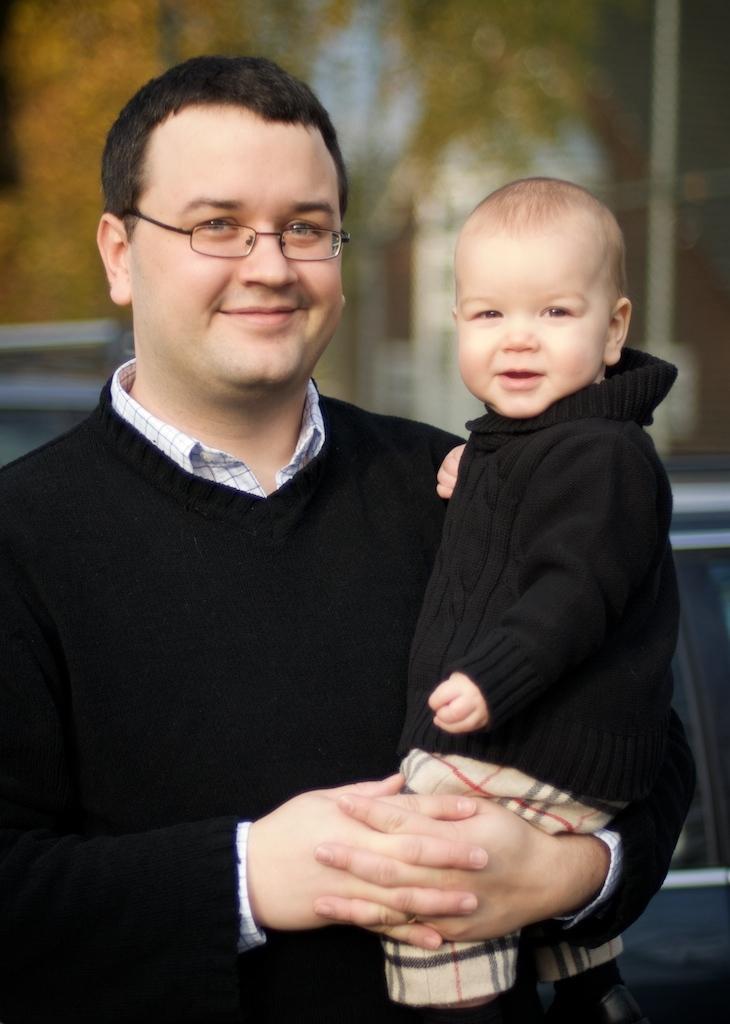Can you describe this image briefly? In the picture we can see a man standing and holding a baby, they are smiling and in the black dresses and behind them we can see trees which are not clearly visible. 